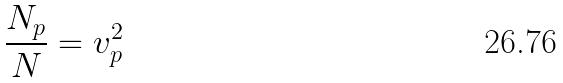Convert formula to latex. <formula><loc_0><loc_0><loc_500><loc_500>\frac { { { N } _ { p } } } { N } = v _ { p } ^ { 2 }</formula> 